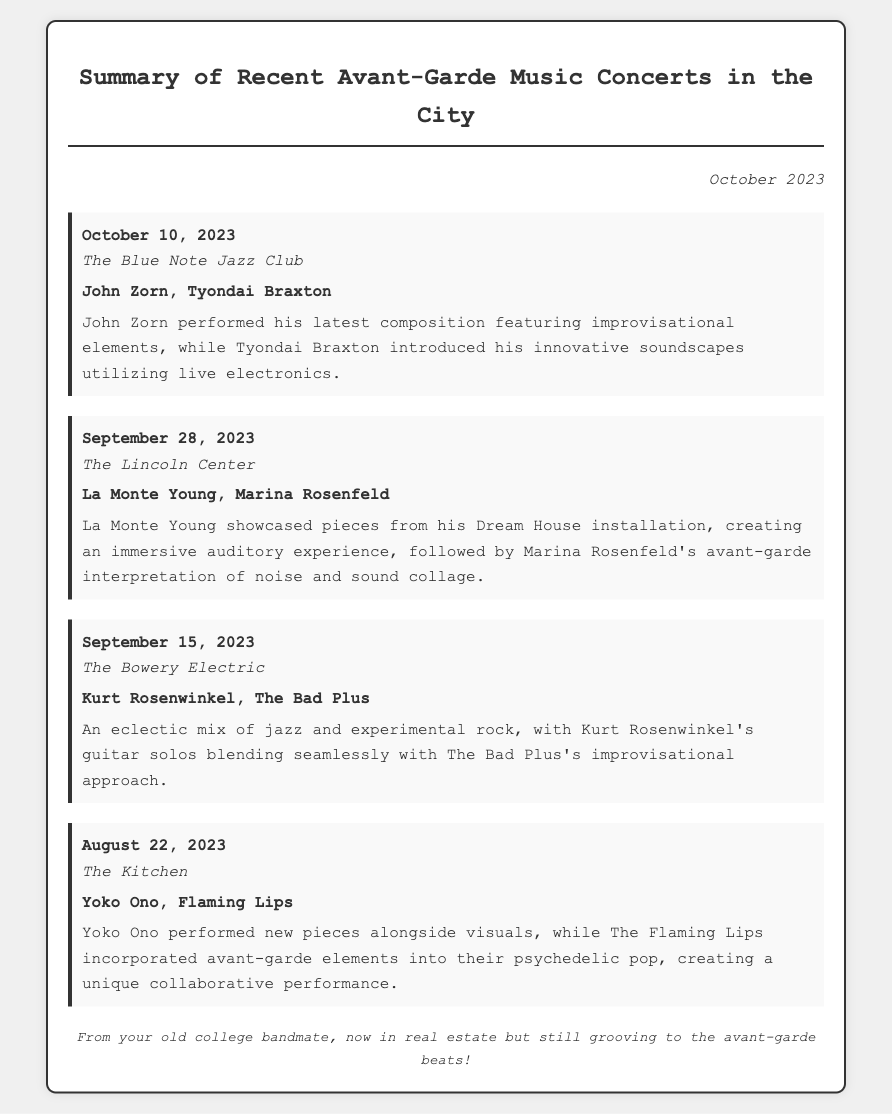What was the date of the concert at The Blue Note Jazz Club? The concert at The Blue Note Jazz Club took place on October 10, 2023.
Answer: October 10, 2023 Who performed at The Lincoln Center on September 28, 2023? The artists who performed at The Lincoln Center were La Monte Young and Marina Rosenfeld.
Answer: La Monte Young, Marina Rosenfeld What type of music did Kurt Rosenwinkel and The Bad Plus represent? Kurt Rosenwinkel and The Bad Plus represented an eclectic mix of jazz and experimental rock.
Answer: Jazz and experimental rock How many notable performances took place at The Kitchen? Only one notable performance took place at The Kitchen featuring Yoko Ono and The Flaming Lips.
Answer: One What was a highlight of John Zorn's performance? A highlight of John Zorn's performance was his latest composition featuring improvisational elements.
Answer: Latest composition featuring improvisational elements Which venue hosted a concert on August 22, 2023? The Kitchen hosted a concert on August 22, 2023.
Answer: The Kitchen Who is mentioned as having performed innovative soundscapes? Tyondai Braxton is mentioned as having performed innovative soundscapes using live electronics.
Answer: Tyondai Braxton What immersive experience did La Monte Young create? La Monte Young created an immersive auditory experience through pieces from his Dream House installation.
Answer: Immersive auditory experience 